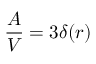<formula> <loc_0><loc_0><loc_500><loc_500>{ \frac { A } { V } } = 3 \delta ( r )</formula> 